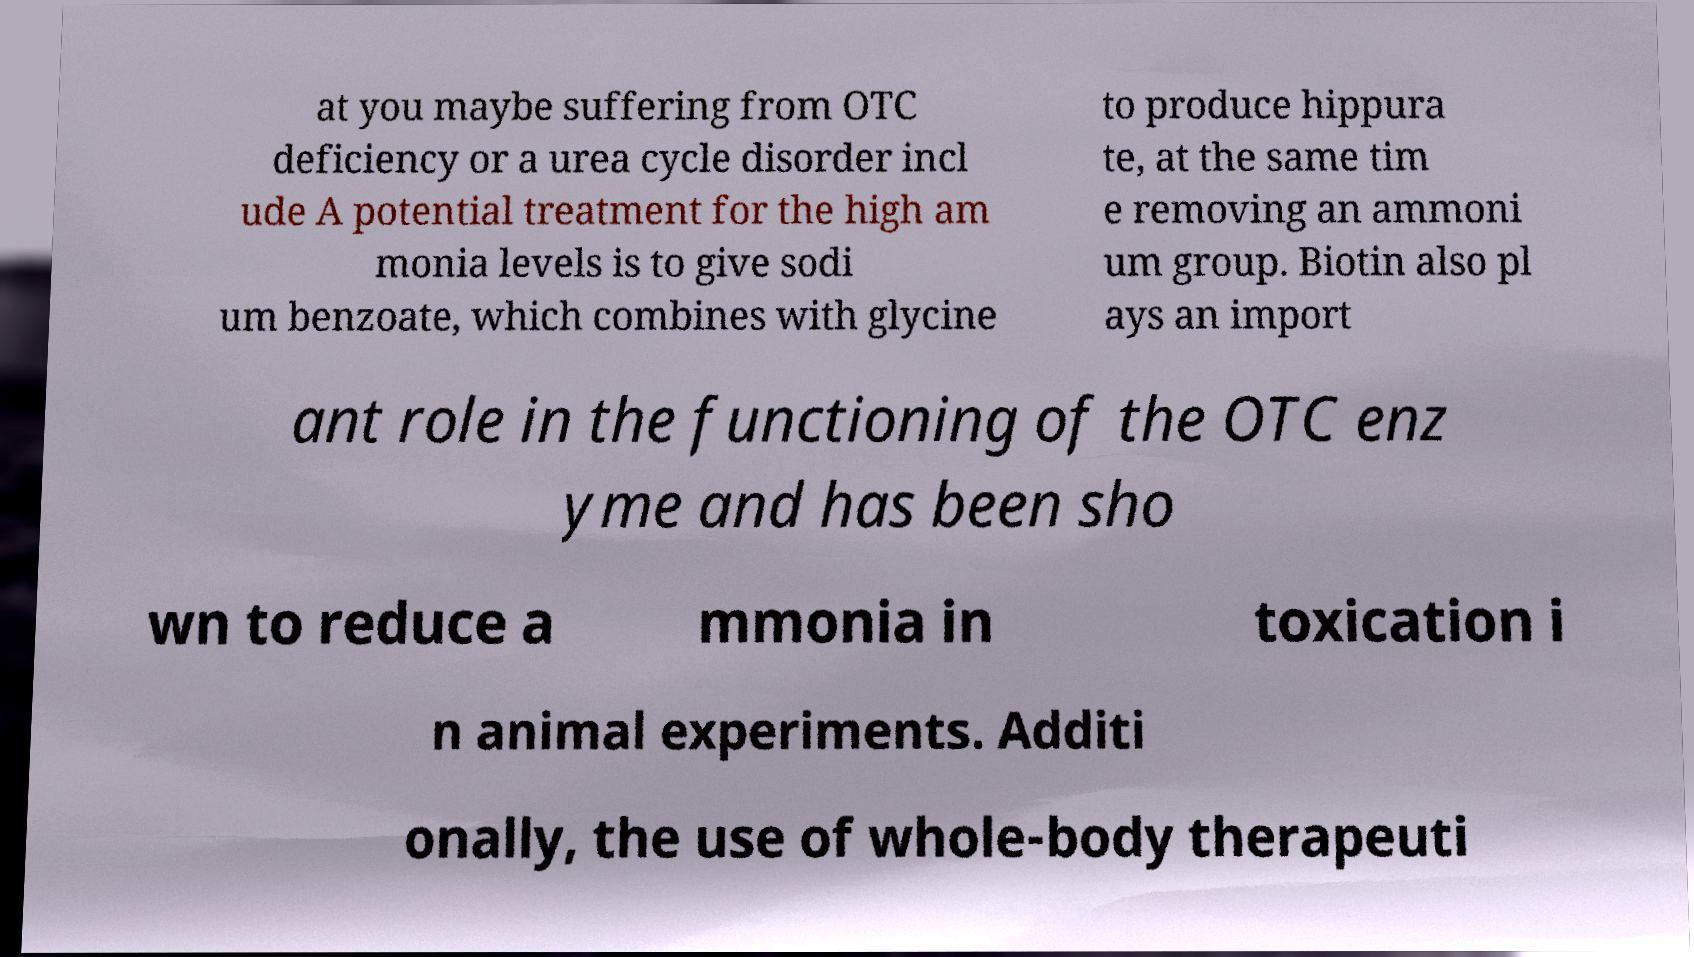What messages or text are displayed in this image? I need them in a readable, typed format. at you maybe suffering from OTC deficiency or a urea cycle disorder incl ude A potential treatment for the high am monia levels is to give sodi um benzoate, which combines with glycine to produce hippura te, at the same tim e removing an ammoni um group. Biotin also pl ays an import ant role in the functioning of the OTC enz yme and has been sho wn to reduce a mmonia in toxication i n animal experiments. Additi onally, the use of whole-body therapeuti 